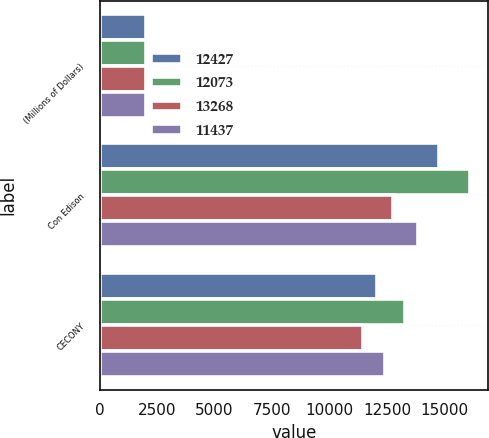Convert chart to OTSL. <chart><loc_0><loc_0><loc_500><loc_500><stacked_bar_chart><ecel><fcel>(Millions of Dollars)<fcel>Con Edison<fcel>CECONY<nl><fcel>12427<fcel>2016<fcel>14774<fcel>12073<nl><fcel>12073<fcel>2016<fcel>16093<fcel>13268<nl><fcel>13268<fcel>2015<fcel>12745<fcel>11437<nl><fcel>11437<fcel>2015<fcel>13856<fcel>12427<nl></chart> 